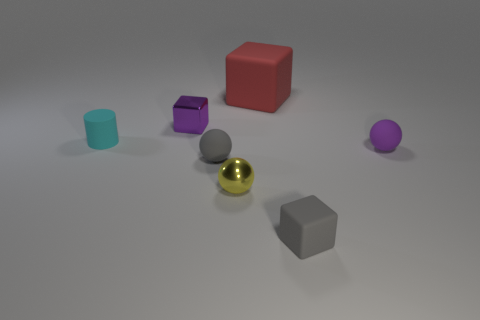Subtract all purple balls. How many balls are left? 2 Add 1 metal cubes. How many objects exist? 8 Subtract all cylinders. How many objects are left? 6 Subtract 3 balls. How many balls are left? 0 Subtract all gray balls. How many purple cubes are left? 1 Subtract all cyan cylinders. Subtract all metallic spheres. How many objects are left? 5 Add 7 red rubber cubes. How many red rubber cubes are left? 8 Add 5 purple metal objects. How many purple metal objects exist? 6 Subtract 0 cyan spheres. How many objects are left? 7 Subtract all green blocks. Subtract all yellow spheres. How many blocks are left? 3 